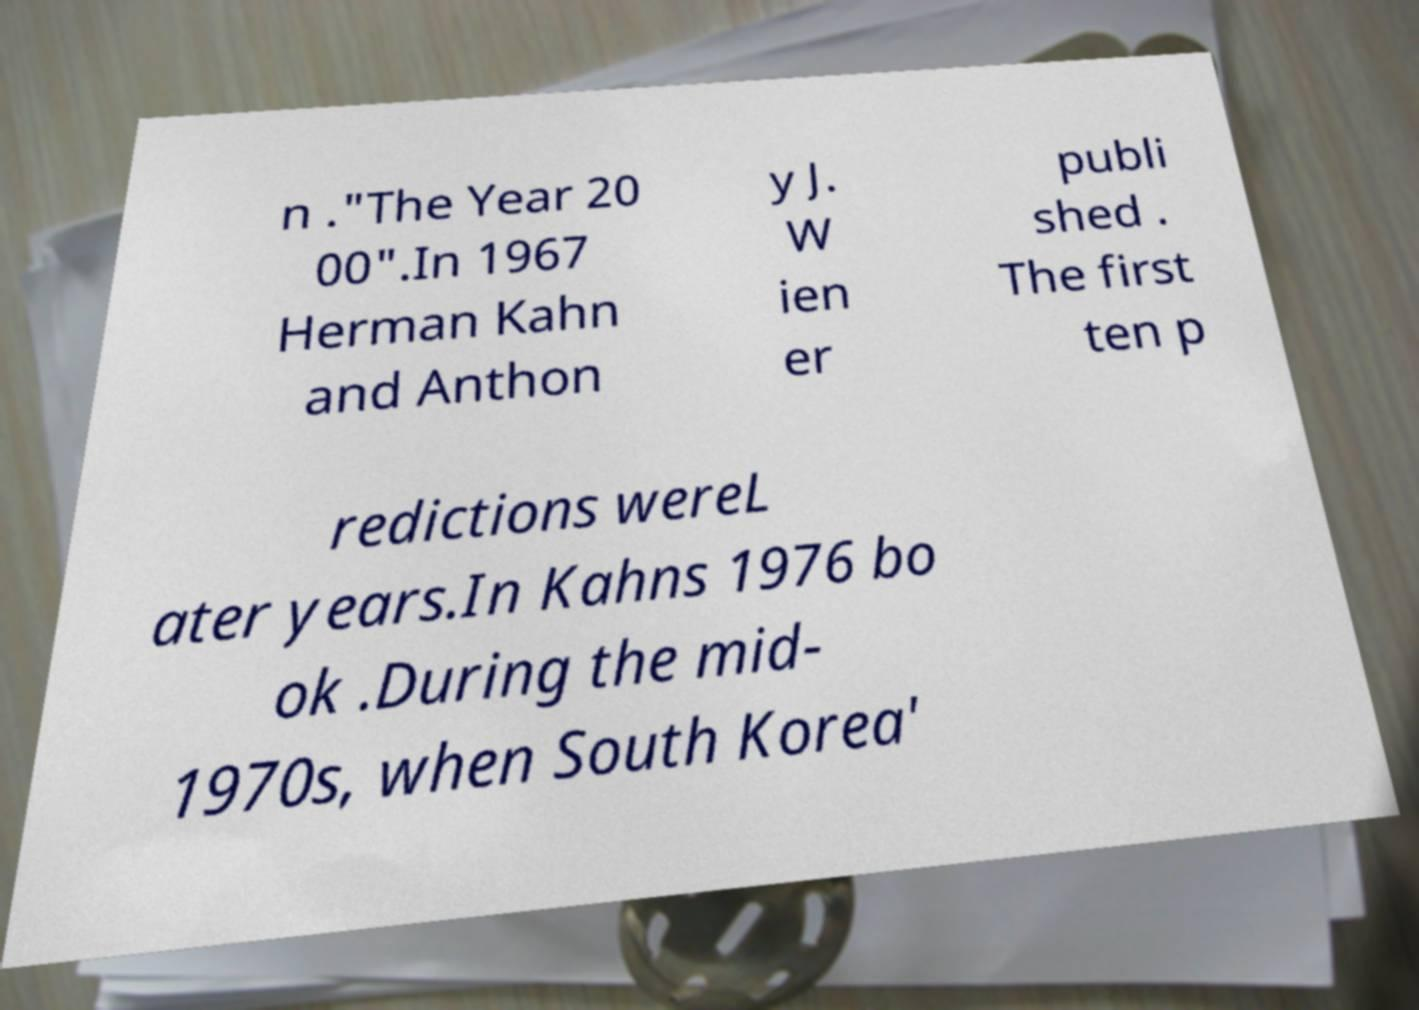Please identify and transcribe the text found in this image. n ."The Year 20 00".In 1967 Herman Kahn and Anthon y J. W ien er publi shed . The first ten p redictions wereL ater years.In Kahns 1976 bo ok .During the mid- 1970s, when South Korea' 